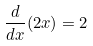<formula> <loc_0><loc_0><loc_500><loc_500>\frac { d } { d x } ( 2 x ) = 2</formula> 